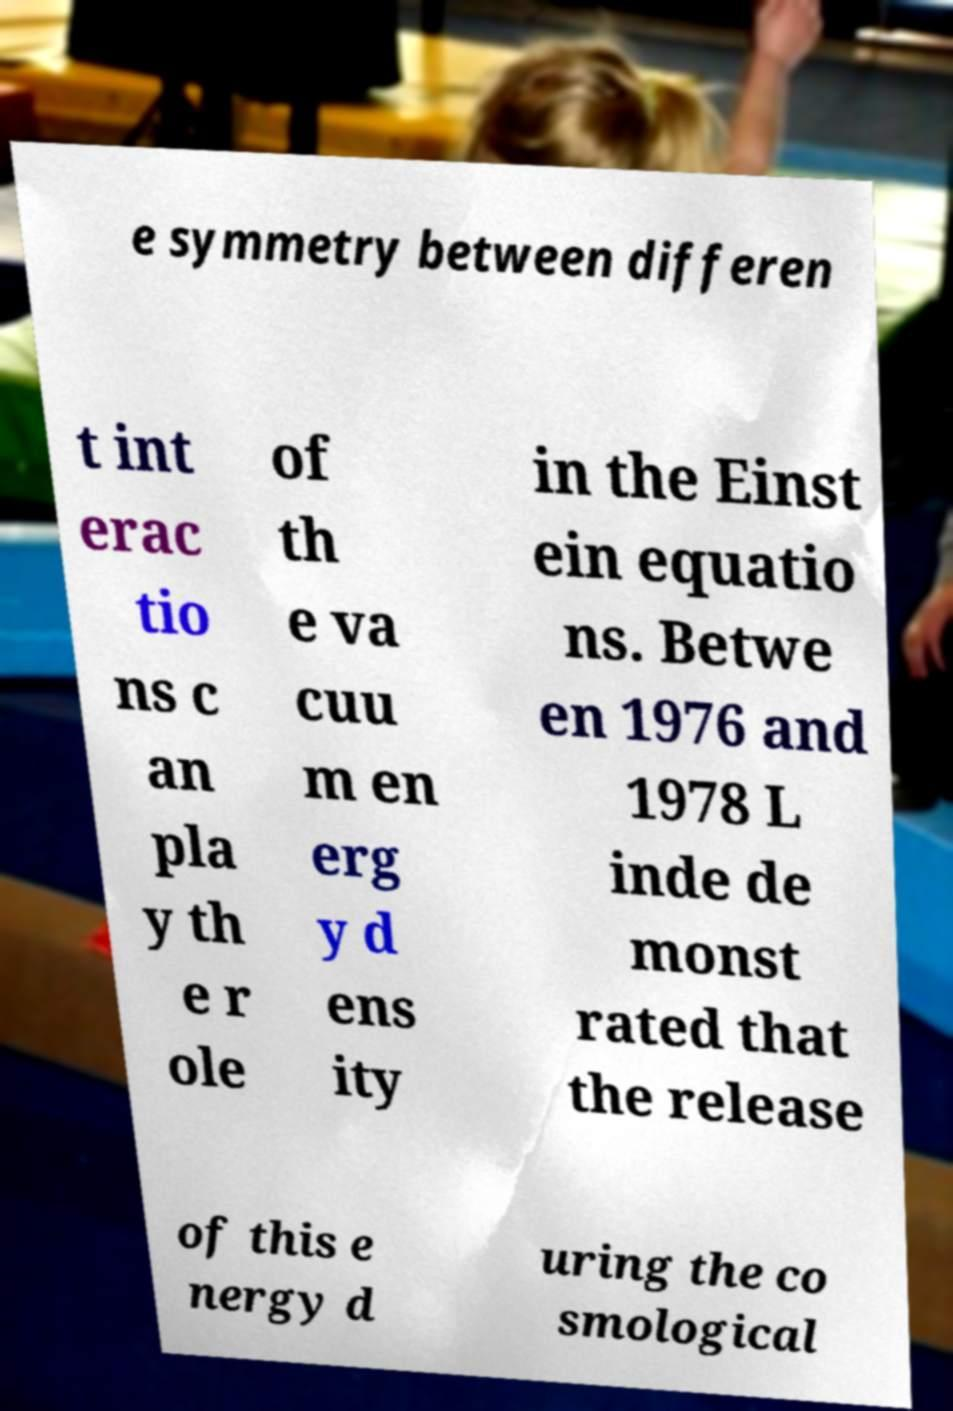Please read and relay the text visible in this image. What does it say? e symmetry between differen t int erac tio ns c an pla y th e r ole of th e va cuu m en erg y d ens ity in the Einst ein equatio ns. Betwe en 1976 and 1978 L inde de monst rated that the release of this e nergy d uring the co smological 